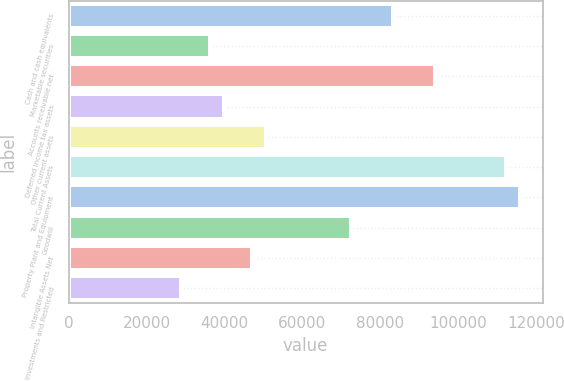<chart> <loc_0><loc_0><loc_500><loc_500><bar_chart><fcel>Cash and cash equivalents<fcel>Marketable securities<fcel>Accounts receivable net<fcel>Deferred income tax assets<fcel>Other current assets<fcel>Total Current Assets<fcel>Property Plant and Equipment<fcel>Goodwill<fcel>Intangible Assets Net<fcel>Investments and Restricted<nl><fcel>83285<fcel>36212<fcel>94148<fcel>39833<fcel>50696<fcel>112253<fcel>115874<fcel>72422<fcel>47075<fcel>28970<nl></chart> 